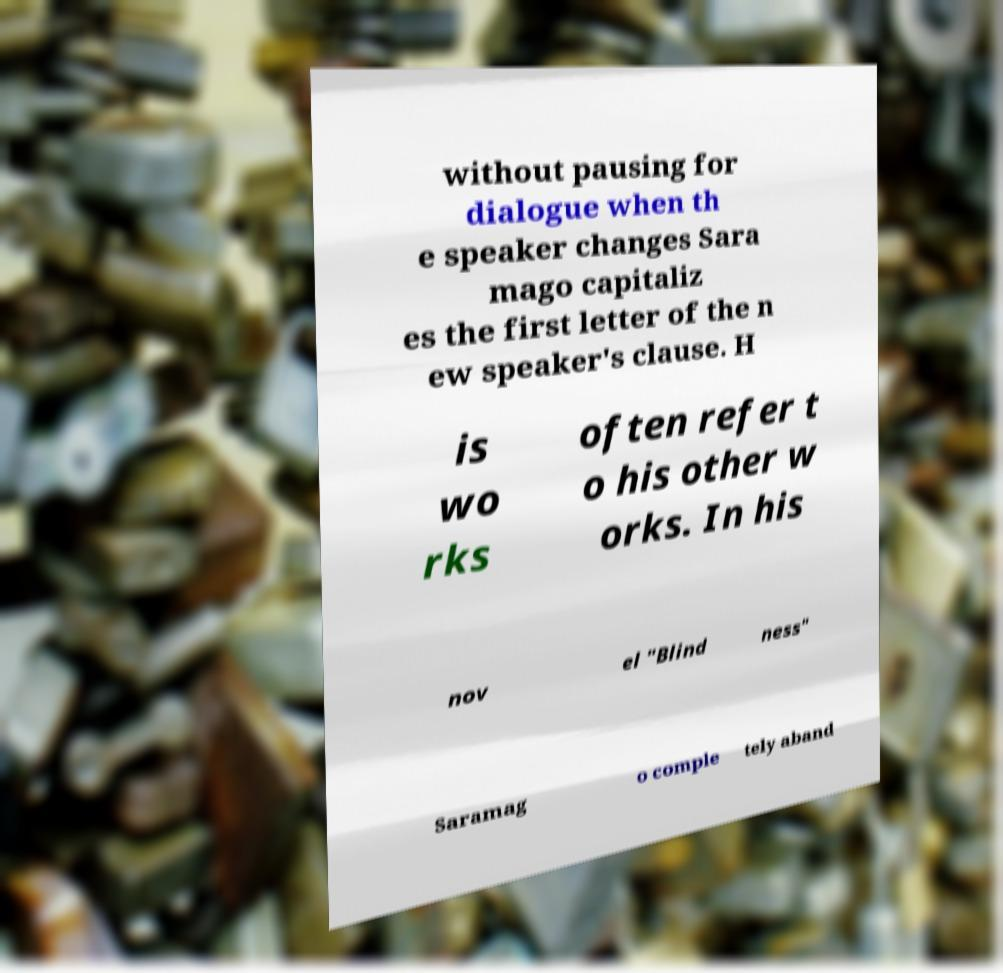For documentation purposes, I need the text within this image transcribed. Could you provide that? without pausing for dialogue when th e speaker changes Sara mago capitaliz es the first letter of the n ew speaker's clause. H is wo rks often refer t o his other w orks. In his nov el "Blind ness" Saramag o comple tely aband 